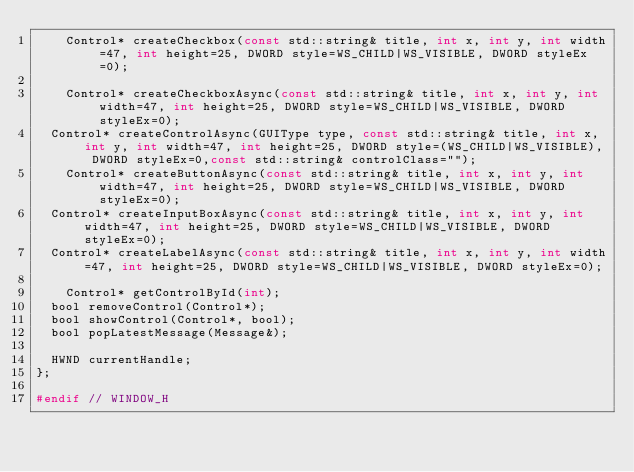<code> <loc_0><loc_0><loc_500><loc_500><_C_>    Control* createCheckbox(const std::string& title, int x, int y, int width=47, int height=25, DWORD style=WS_CHILD|WS_VISIBLE, DWORD styleEx=0);

    Control* createCheckboxAsync(const std::string& title, int x, int y, int width=47, int height=25, DWORD style=WS_CHILD|WS_VISIBLE, DWORD styleEx=0);
	Control* createControlAsync(GUIType type, const std::string& title, int x, int y, int width=47, int height=25, DWORD style=(WS_CHILD|WS_VISIBLE), DWORD styleEx=0,const std::string& controlClass="");
    Control* createButtonAsync(const std::string& title, int x, int y, int width=47, int height=25, DWORD style=WS_CHILD|WS_VISIBLE, DWORD styleEx=0);
	Control* createInputBoxAsync(const std::string& title, int x, int y, int width=47, int height=25, DWORD style=WS_CHILD|WS_VISIBLE, DWORD styleEx=0);
	Control* createLabelAsync(const std::string& title, int x, int y, int width=47, int height=25, DWORD style=WS_CHILD|WS_VISIBLE, DWORD styleEx=0);

    Control* getControlById(int);
	bool removeControl(Control*);
	bool showControl(Control*, bool);
	bool popLatestMessage(Message&);

	HWND currentHandle;
};

#endif // WINDOW_H
</code> 